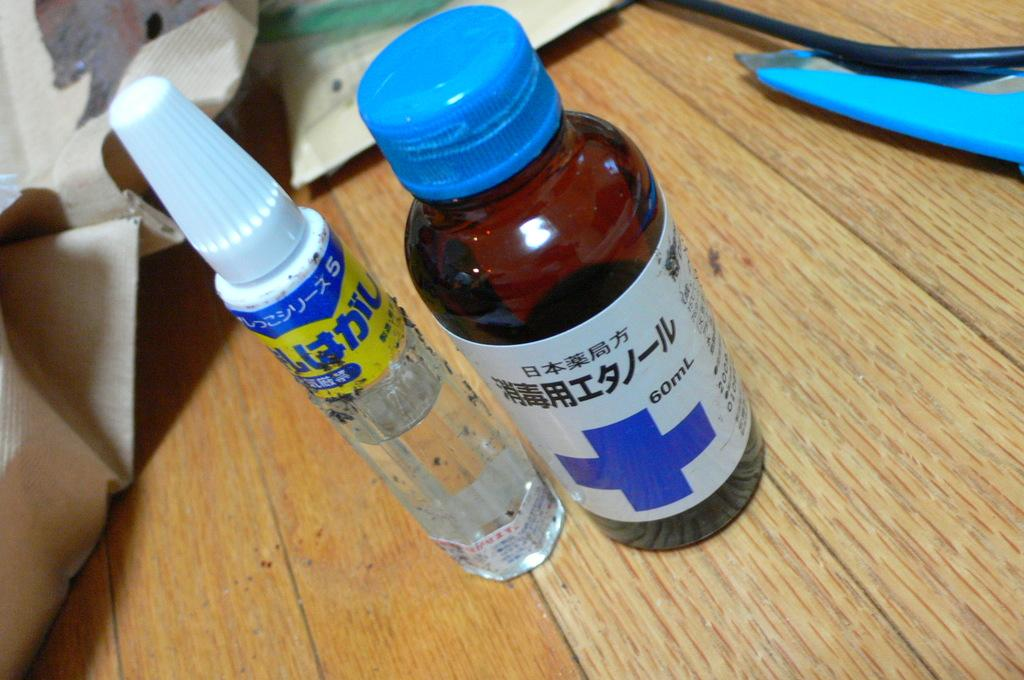<image>
Give a short and clear explanation of the subsequent image. Two bottles, one clear and one brown, with labels written in Japanese. 